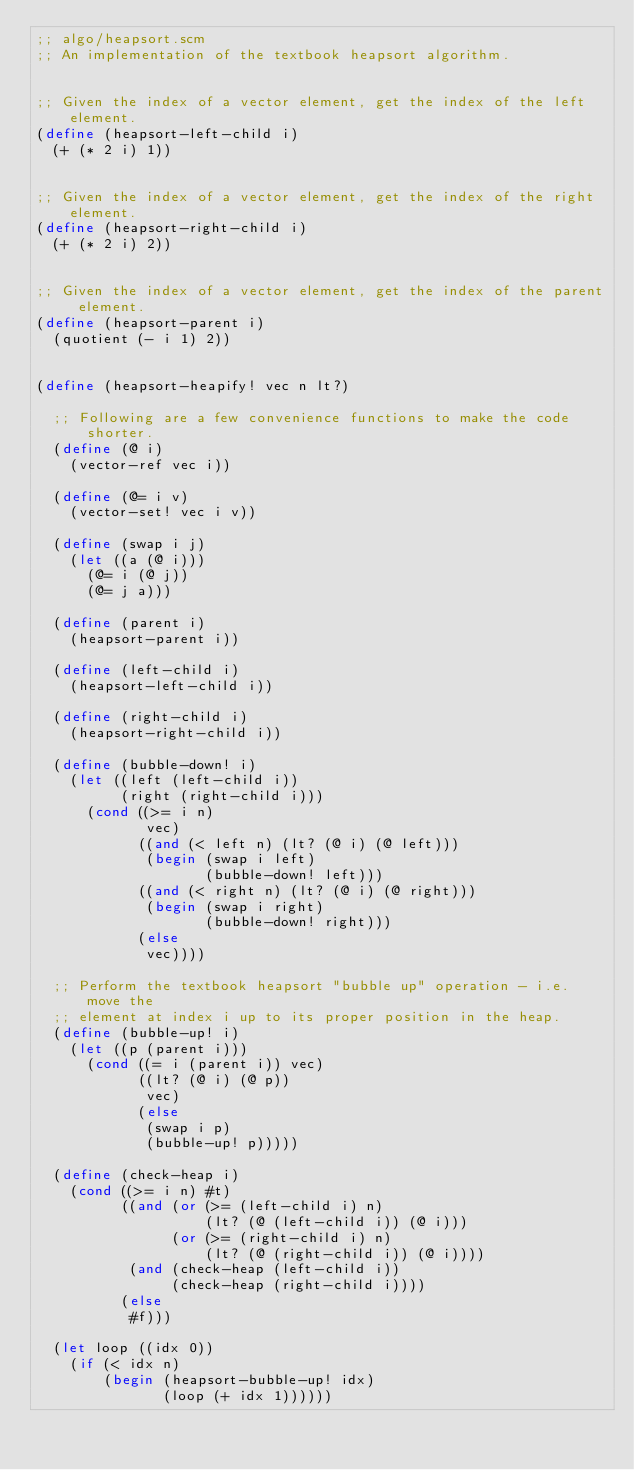Convert code to text. <code><loc_0><loc_0><loc_500><loc_500><_Scheme_>;; algo/heapsort.scm
;; An implementation of the textbook heapsort algorithm.


;; Given the index of a vector element, get the index of the left element.
(define (heapsort-left-child i)
  (+ (* 2 i) 1))


;; Given the index of a vector element, get the index of the right element.
(define (heapsort-right-child i)
  (+ (* 2 i) 2))


;; Given the index of a vector element, get the index of the parent element.
(define (heapsort-parent i)
  (quotient (- i 1) 2))


(define (heapsort-heapify! vec n lt?)

  ;; Following are a few convenience functions to make the code shorter.
  (define (@ i)
    (vector-ref vec i))

  (define (@= i v)
    (vector-set! vec i v))

  (define (swap i j)
    (let ((a (@ i)))
      (@= i (@ j))
      (@= j a)))

  (define (parent i)
    (heapsort-parent i))

  (define (left-child i)
    (heapsort-left-child i))

  (define (right-child i)
    (heapsort-right-child i))

  (define (bubble-down! i)
    (let ((left (left-child i))
          (right (right-child i)))
      (cond ((>= i n) 
             vec)
            ((and (< left n) (lt? (@ i) (@ left)))
             (begin (swap i left)
                    (bubble-down! left)))
            ((and (< right n) (lt? (@ i) (@ right)))
             (begin (swap i right)
                    (bubble-down! right)))
            (else
             vec))))

  ;; Perform the textbook heapsort "bubble up" operation - i.e. move the
  ;; element at index i up to its proper position in the heap.
  (define (bubble-up! i)
    (let ((p (parent i)))
      (cond ((= i (parent i)) vec)
            ((lt? (@ i) (@ p))
             vec)
            (else
             (swap i p)
             (bubble-up! p)))))

  (define (check-heap i)
    (cond ((>= i n) #t)
          ((and (or (>= (left-child i) n)
                    (lt? (@ (left-child i)) (@ i)))
                (or (>= (right-child i) n)
                    (lt? (@ (right-child i)) (@ i))))
           (and (check-heap (left-child i))
                (check-heap (right-child i))))
          (else
           #f)))

  (let loop ((idx 0))
    (if (< idx n)
        (begin (heapsort-bubble-up! idx)
               (loop (+ idx 1))))))
</code> 